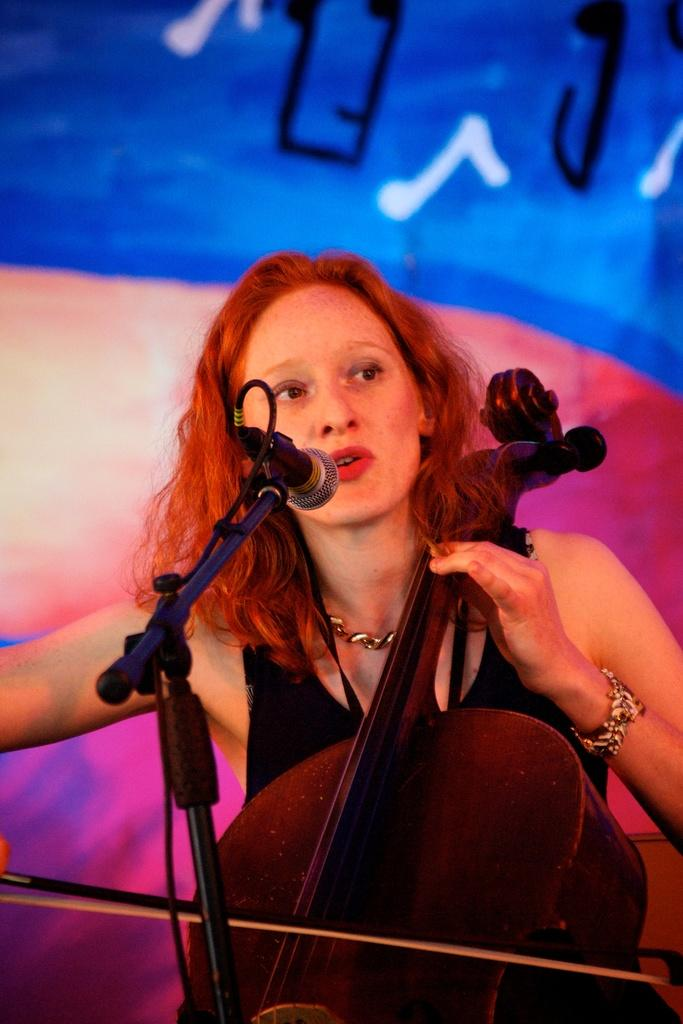Who is the main subject in the image? There is a woman in the image. What is the woman doing in the image? The woman is sitting and playing a violin. Is the woman also doing something else in the image? Yes, the woman is singing. What objects are present in the image that might be related to the woman's performance? There is a microphone and a stand in the image. What type of account does the tiger have in the image? There is no tiger present in the image, so it is not possible to determine if it has any account. 